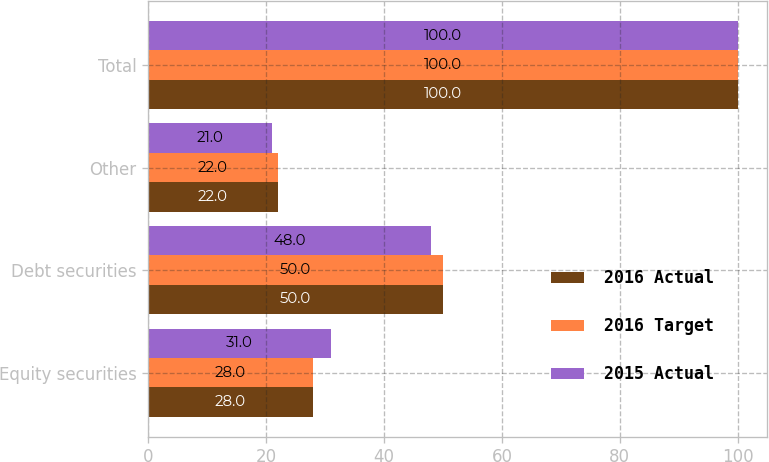Convert chart. <chart><loc_0><loc_0><loc_500><loc_500><stacked_bar_chart><ecel><fcel>Equity securities<fcel>Debt securities<fcel>Other<fcel>Total<nl><fcel>2016 Actual<fcel>28<fcel>50<fcel>22<fcel>100<nl><fcel>2016 Target<fcel>28<fcel>50<fcel>22<fcel>100<nl><fcel>2015 Actual<fcel>31<fcel>48<fcel>21<fcel>100<nl></chart> 